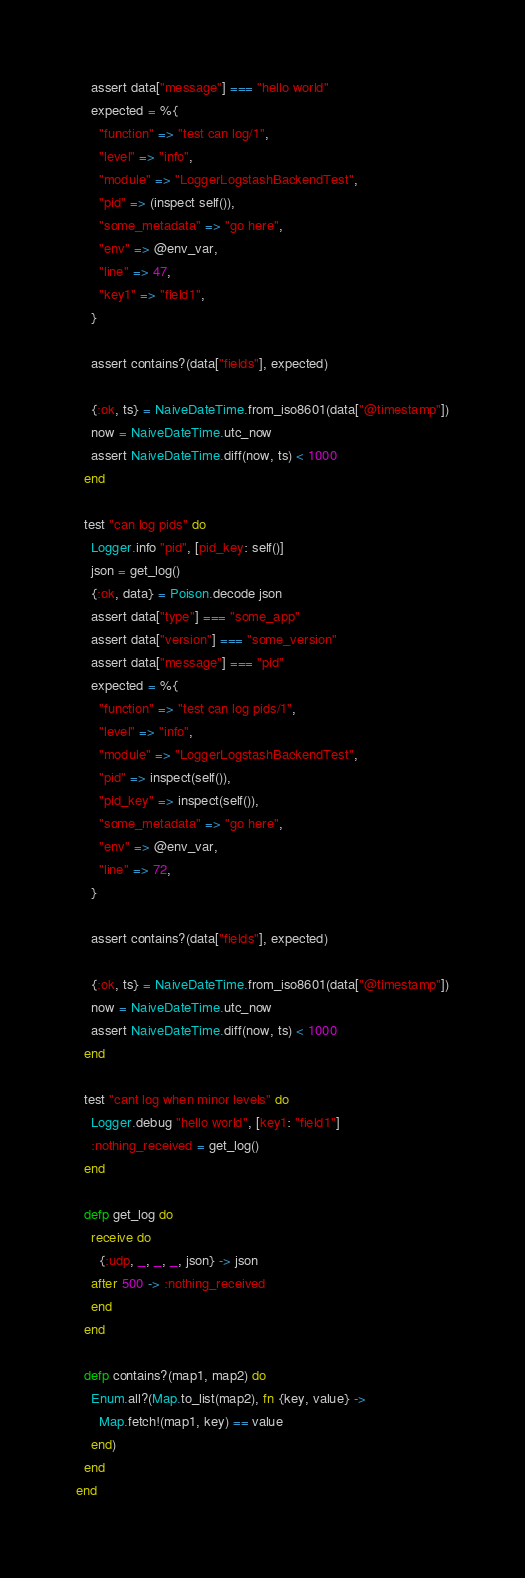Convert code to text. <code><loc_0><loc_0><loc_500><loc_500><_Elixir_>    assert data["message"] === "hello world"
    expected = %{
      "function" => "test can log/1",
      "level" => "info",
      "module" => "LoggerLogstashBackendTest",
      "pid" => (inspect self()),
      "some_metadata" => "go here",
      "env" => @env_var,
      "line" => 47,
      "key1" => "field1",
    }

    assert contains?(data["fields"], expected)

    {:ok, ts} = NaiveDateTime.from_iso8601(data["@timestamp"])
    now = NaiveDateTime.utc_now
    assert NaiveDateTime.diff(now, ts) < 1000
  end

  test "can log pids" do
    Logger.info "pid", [pid_key: self()]
    json = get_log()
    {:ok, data} = Poison.decode json
    assert data["type"] === "some_app"
    assert data["version"] === "some_version"
    assert data["message"] === "pid"
    expected = %{
      "function" => "test can log pids/1",
      "level" => "info",
      "module" => "LoggerLogstashBackendTest",
      "pid" => inspect(self()),
      "pid_key" => inspect(self()),
      "some_metadata" => "go here",
      "env" => @env_var,
      "line" => 72,
    }

    assert contains?(data["fields"], expected)

    {:ok, ts} = NaiveDateTime.from_iso8601(data["@timestamp"])
    now = NaiveDateTime.utc_now
    assert NaiveDateTime.diff(now, ts) < 1000
  end

  test "cant log when minor levels" do
    Logger.debug "hello world", [key1: "field1"]
    :nothing_received = get_log()
  end

  defp get_log do
    receive do
      {:udp, _, _, _, json} -> json
    after 500 -> :nothing_received
    end
  end

  defp contains?(map1, map2) do
    Enum.all?(Map.to_list(map2), fn {key, value} ->
      Map.fetch!(map1, key) == value
    end)
  end
end
</code> 